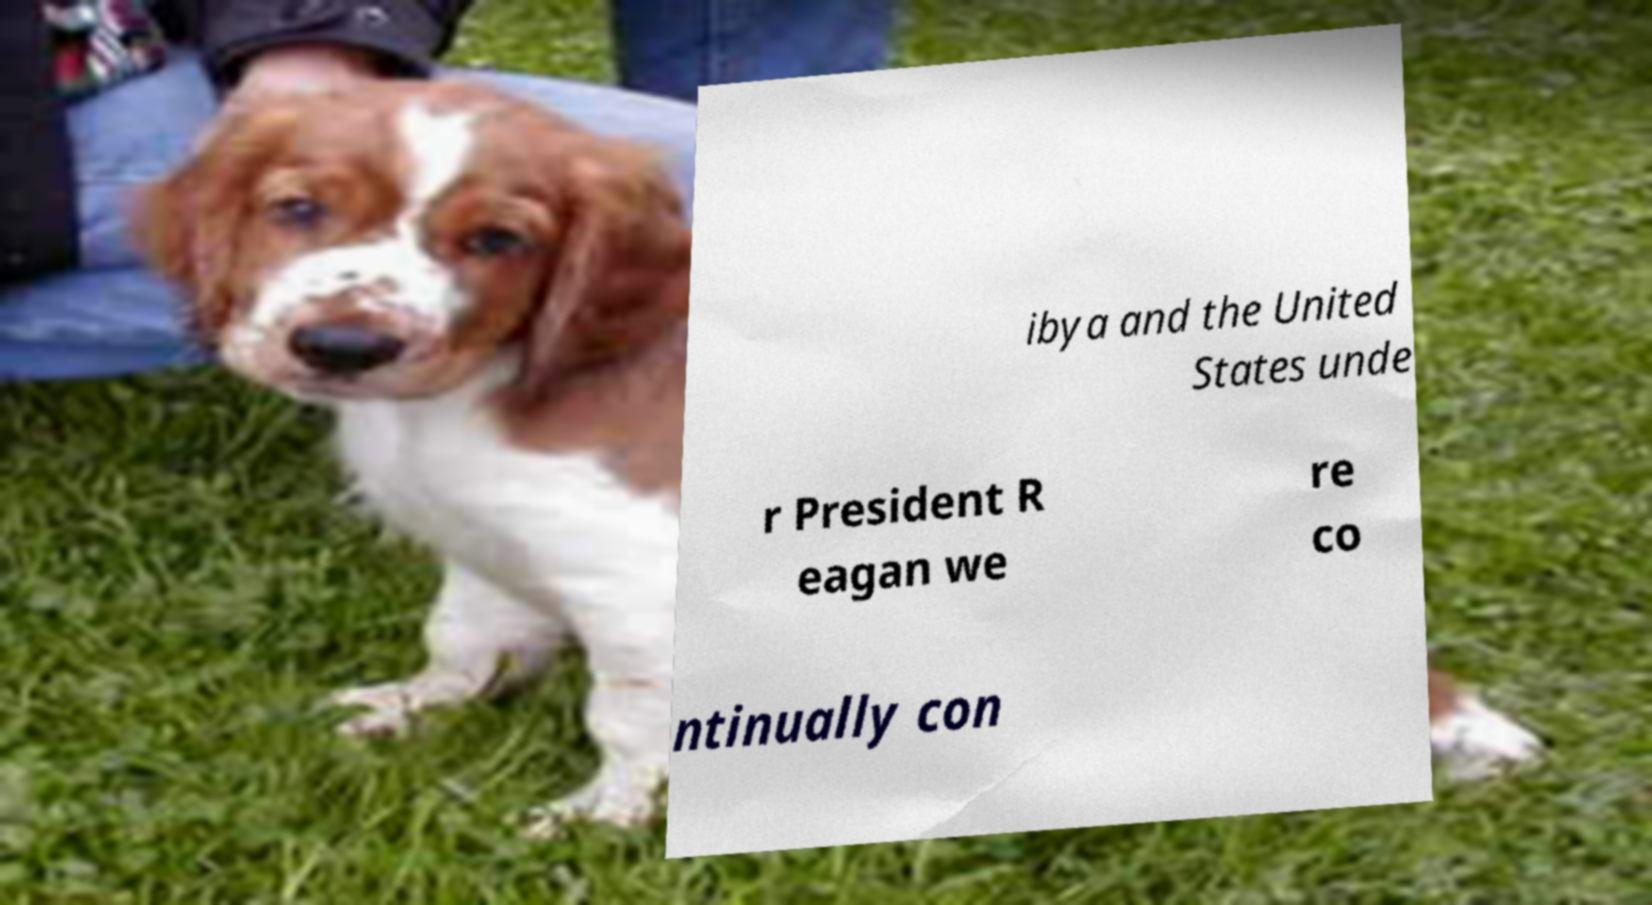Could you extract and type out the text from this image? ibya and the United States unde r President R eagan we re co ntinually con 